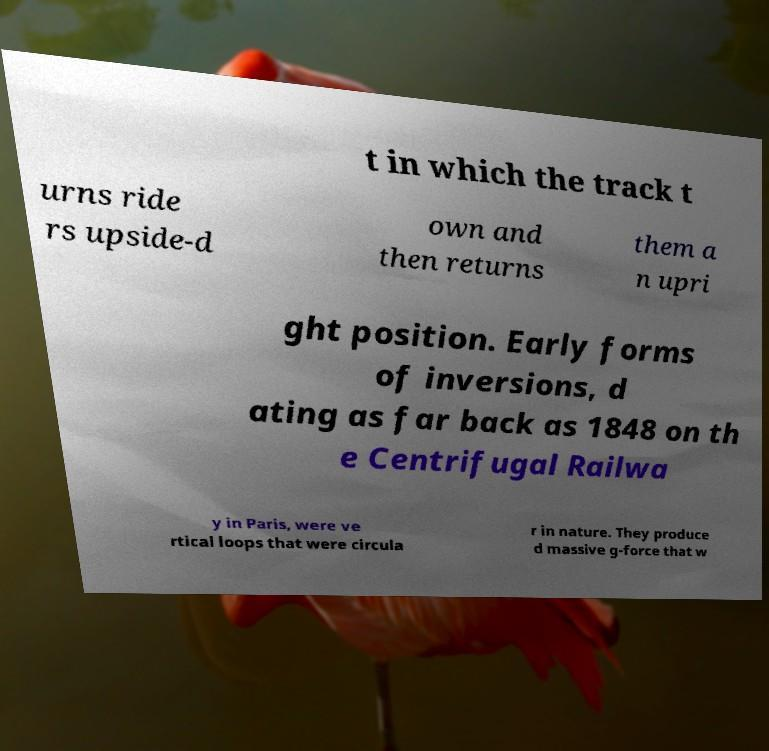Can you read and provide the text displayed in the image?This photo seems to have some interesting text. Can you extract and type it out for me? t in which the track t urns ride rs upside-d own and then returns them a n upri ght position. Early forms of inversions, d ating as far back as 1848 on th e Centrifugal Railwa y in Paris, were ve rtical loops that were circula r in nature. They produce d massive g-force that w 